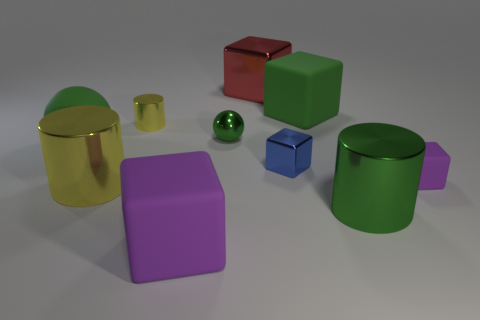What number of blocks are there? The image depicts more than just a single type of shape; there are a total of 10 objects consisting of blocks, cylinders, and spheres. 